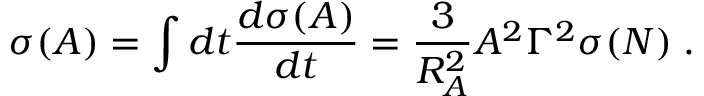<formula> <loc_0><loc_0><loc_500><loc_500>\sigma ( A ) = \int d t \frac { d \sigma ( A ) } { d t } = \frac { 3 } { R _ { A } ^ { 2 } } A ^ { 2 } \Gamma ^ { 2 } \sigma ( N ) \, .</formula> 